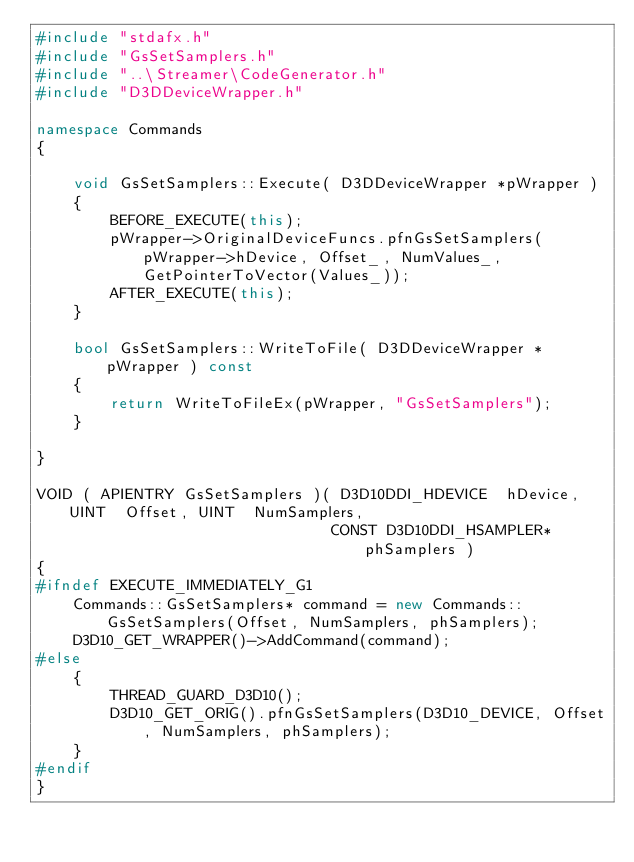<code> <loc_0><loc_0><loc_500><loc_500><_C++_>#include "stdafx.h"
#include "GsSetSamplers.h"
#include "..\Streamer\CodeGenerator.h"
#include "D3DDeviceWrapper.h"

namespace Commands
{

	void GsSetSamplers::Execute( D3DDeviceWrapper *pWrapper )
	{
		BEFORE_EXECUTE(this);
		pWrapper->OriginalDeviceFuncs.pfnGsSetSamplers(pWrapper->hDevice, Offset_, NumValues_, GetPointerToVector(Values_));
		AFTER_EXECUTE(this); 
	}

	bool GsSetSamplers::WriteToFile( D3DDeviceWrapper *pWrapper ) const
	{
		return WriteToFileEx(pWrapper, "GsSetSamplers");
	}

}

VOID ( APIENTRY GsSetSamplers )( D3D10DDI_HDEVICE  hDevice, UINT  Offset, UINT  NumSamplers, 
								CONST D3D10DDI_HSAMPLER*  phSamplers )
{
#ifndef EXECUTE_IMMEDIATELY_G1
	Commands::GsSetSamplers* command = new Commands::GsSetSamplers(Offset, NumSamplers, phSamplers);
	D3D10_GET_WRAPPER()->AddCommand(command);
#else
	{
		THREAD_GUARD_D3D10();
		D3D10_GET_ORIG().pfnGsSetSamplers(D3D10_DEVICE, Offset, NumSamplers, phSamplers);
	}
#endif
}</code> 